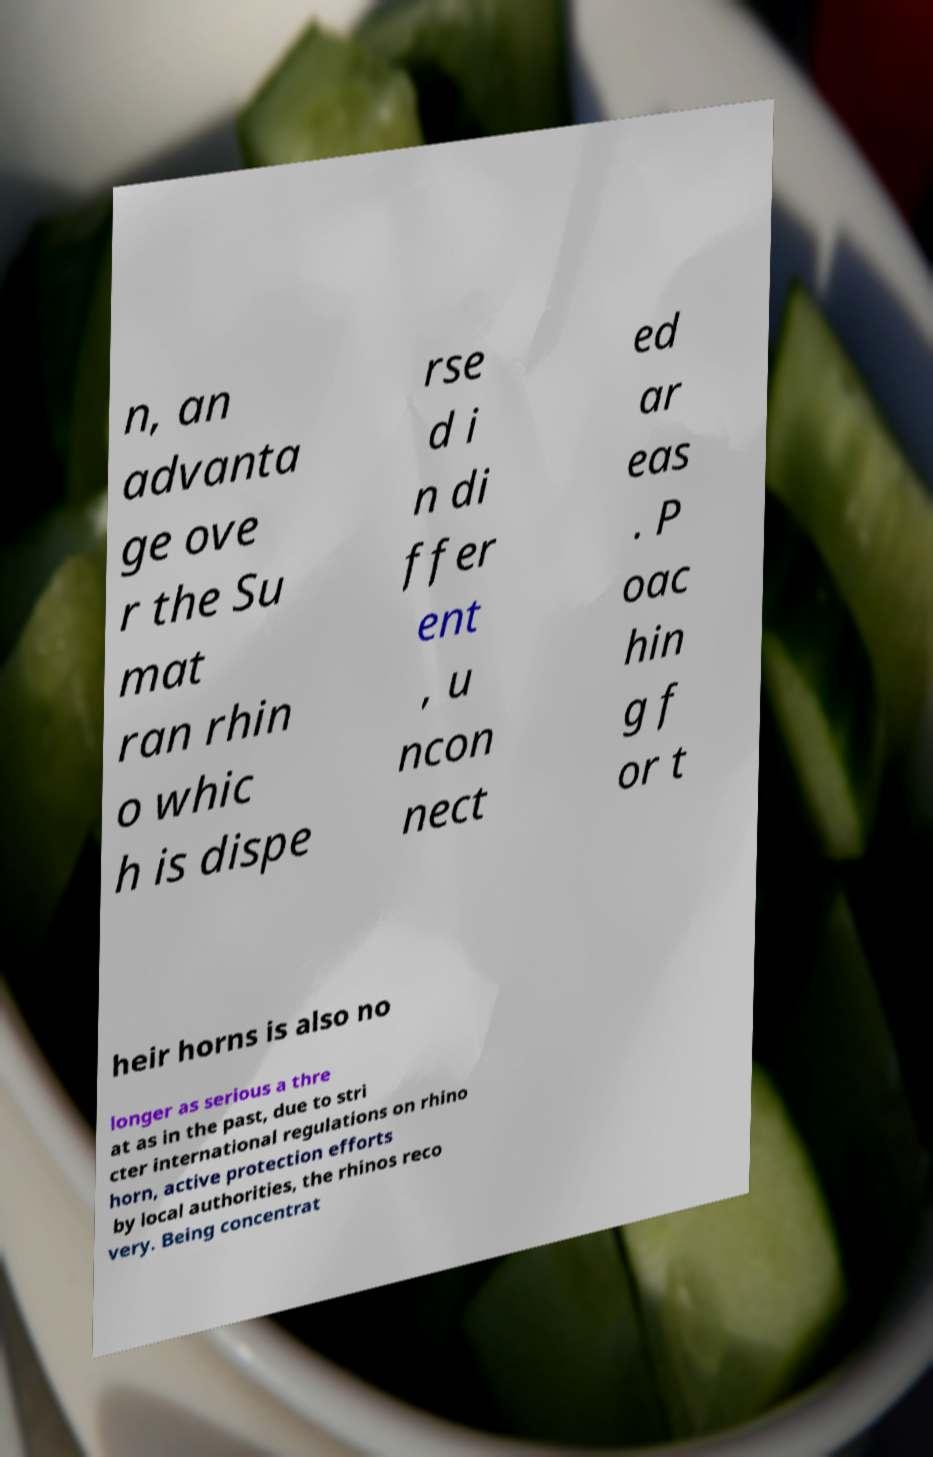Please identify and transcribe the text found in this image. n, an advanta ge ove r the Su mat ran rhin o whic h is dispe rse d i n di ffer ent , u ncon nect ed ar eas . P oac hin g f or t heir horns is also no longer as serious a thre at as in the past, due to stri cter international regulations on rhino horn, active protection efforts by local authorities, the rhinos reco very. Being concentrat 